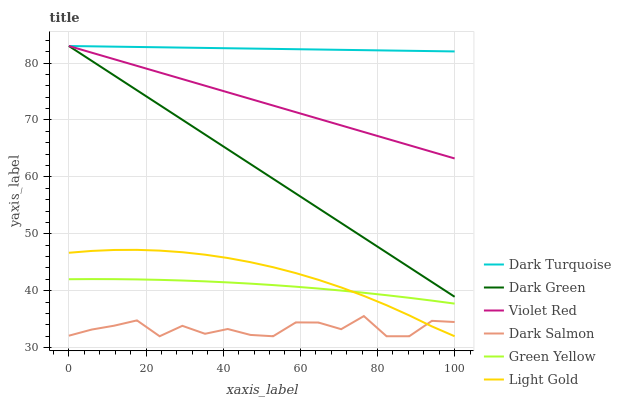Does Dark Turquoise have the minimum area under the curve?
Answer yes or no. No. Does Dark Salmon have the maximum area under the curve?
Answer yes or no. No. Is Dark Salmon the smoothest?
Answer yes or no. No. Is Dark Turquoise the roughest?
Answer yes or no. No. Does Dark Turquoise have the lowest value?
Answer yes or no. No. Does Dark Salmon have the highest value?
Answer yes or no. No. Is Dark Salmon less than Green Yellow?
Answer yes or no. Yes. Is Violet Red greater than Light Gold?
Answer yes or no. Yes. Does Dark Salmon intersect Green Yellow?
Answer yes or no. No. 